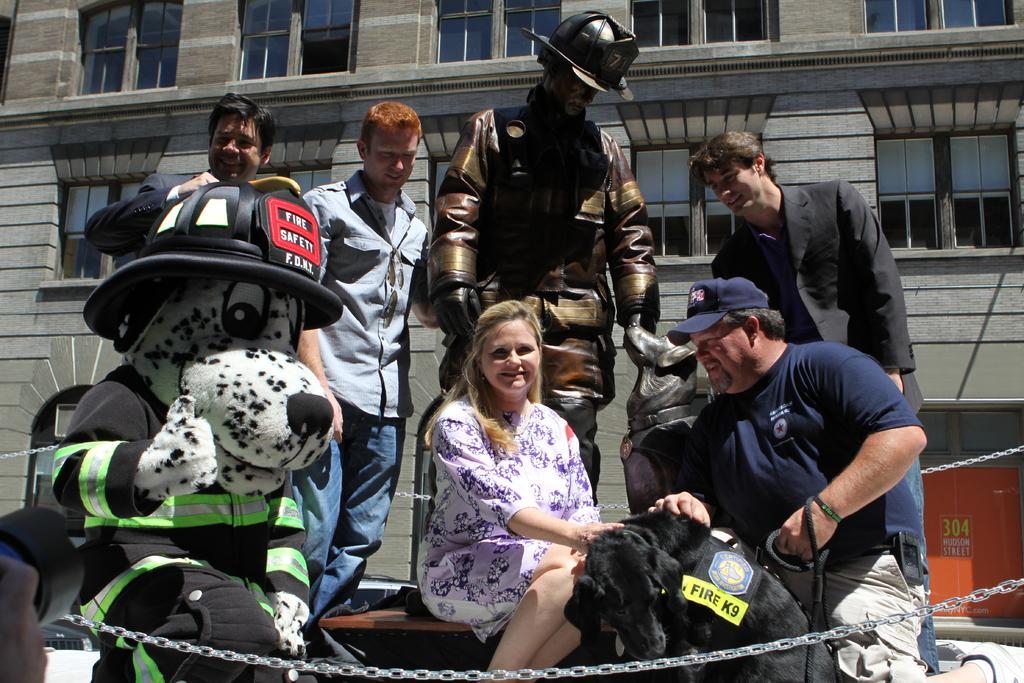Could you give a brief overview of what you see in this image? In this picture we can see a group of people, statue, cap, chains, dog and some objects and in the background we can see a building with windows. 